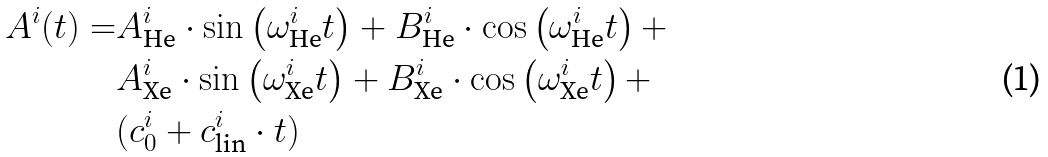Convert formula to latex. <formula><loc_0><loc_0><loc_500><loc_500>A ^ { i } ( t ) = & A _ { \text {He} } ^ { i } \cdot \sin \left ( \omega _ { \text {He} } ^ { i } t \right ) + B _ { \text {He} } ^ { i } \cdot \cos \left ( \omega _ { \text {He} } ^ { i } t \right ) + \\ & A _ { \text {Xe} } ^ { i } \cdot \sin \left ( \omega _ { \text {Xe} } ^ { i } t \right ) + B _ { \text {Xe} } ^ { i } \cdot \cos \left ( \omega _ { \text {Xe} } ^ { i } t \right ) + \\ & ( c _ { 0 } ^ { i } + c _ { \text {lin} } ^ { i } \cdot t )</formula> 